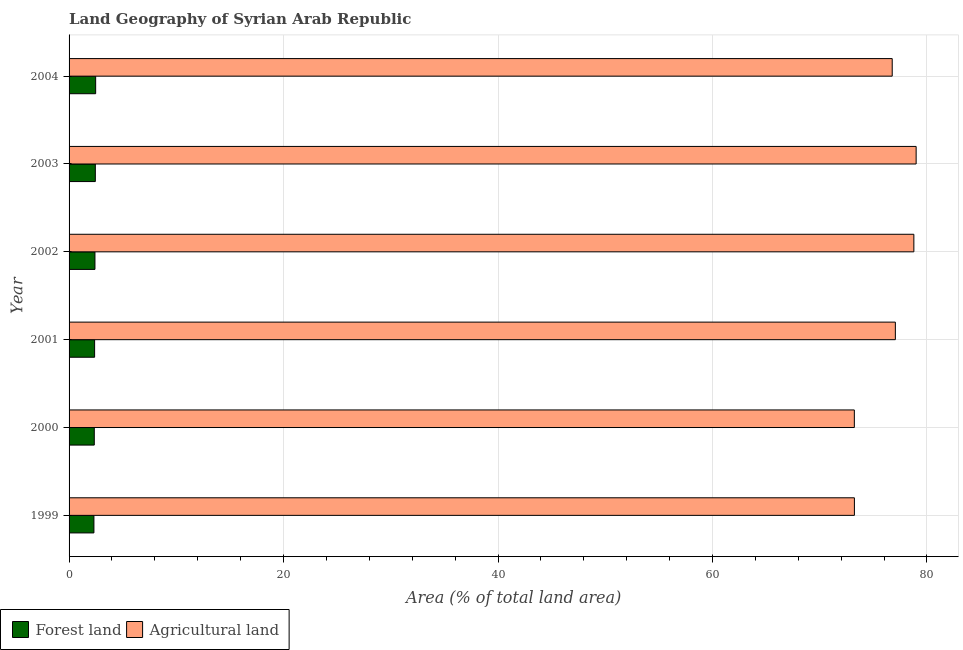How many groups of bars are there?
Your answer should be compact. 6. Are the number of bars per tick equal to the number of legend labels?
Make the answer very short. Yes. Are the number of bars on each tick of the Y-axis equal?
Provide a short and direct response. Yes. What is the percentage of land area under forests in 1999?
Provide a succinct answer. 2.32. Across all years, what is the maximum percentage of land area under agriculture?
Ensure brevity in your answer.  78.99. Across all years, what is the minimum percentage of land area under agriculture?
Provide a succinct answer. 73.23. What is the total percentage of land area under forests in the graph?
Provide a short and direct response. 14.39. What is the difference between the percentage of land area under agriculture in 2001 and that in 2004?
Offer a very short reply. 0.29. What is the difference between the percentage of land area under agriculture in 2001 and the percentage of land area under forests in 2003?
Offer a terse response. 74.61. What is the average percentage of land area under agriculture per year?
Offer a very short reply. 76.34. In the year 2003, what is the difference between the percentage of land area under forests and percentage of land area under agriculture?
Your answer should be compact. -76.54. Is the difference between the percentage of land area under forests in 2000 and 2001 greater than the difference between the percentage of land area under agriculture in 2000 and 2001?
Your answer should be compact. Yes. What is the difference between the highest and the second highest percentage of land area under forests?
Ensure brevity in your answer.  0.03. What is the difference between the highest and the lowest percentage of land area under forests?
Keep it short and to the point. 0.16. In how many years, is the percentage of land area under forests greater than the average percentage of land area under forests taken over all years?
Make the answer very short. 3. Is the sum of the percentage of land area under agriculture in 2000 and 2002 greater than the maximum percentage of land area under forests across all years?
Provide a short and direct response. Yes. What does the 1st bar from the top in 2004 represents?
Provide a succinct answer. Agricultural land. What does the 1st bar from the bottom in 2000 represents?
Provide a succinct answer. Forest land. How many bars are there?
Your response must be concise. 12. Are all the bars in the graph horizontal?
Provide a short and direct response. Yes. What is the difference between two consecutive major ticks on the X-axis?
Offer a terse response. 20. Does the graph contain any zero values?
Ensure brevity in your answer.  No. Does the graph contain grids?
Ensure brevity in your answer.  Yes. Where does the legend appear in the graph?
Your answer should be compact. Bottom left. How many legend labels are there?
Offer a very short reply. 2. How are the legend labels stacked?
Offer a very short reply. Horizontal. What is the title of the graph?
Give a very brief answer. Land Geography of Syrian Arab Republic. What is the label or title of the X-axis?
Offer a very short reply. Area (% of total land area). What is the label or title of the Y-axis?
Ensure brevity in your answer.  Year. What is the Area (% of total land area) of Forest land in 1999?
Provide a succinct answer. 2.32. What is the Area (% of total land area) of Agricultural land in 1999?
Your answer should be very brief. 73.23. What is the Area (% of total land area) in Forest land in 2000?
Offer a terse response. 2.35. What is the Area (% of total land area) in Agricultural land in 2000?
Your response must be concise. 73.23. What is the Area (% of total land area) of Forest land in 2001?
Give a very brief answer. 2.38. What is the Area (% of total land area) in Agricultural land in 2001?
Make the answer very short. 77.05. What is the Area (% of total land area) of Forest land in 2002?
Offer a terse response. 2.41. What is the Area (% of total land area) in Agricultural land in 2002?
Your answer should be very brief. 78.78. What is the Area (% of total land area) of Forest land in 2003?
Provide a short and direct response. 2.45. What is the Area (% of total land area) in Agricultural land in 2003?
Keep it short and to the point. 78.99. What is the Area (% of total land area) in Forest land in 2004?
Offer a terse response. 2.48. What is the Area (% of total land area) in Agricultural land in 2004?
Your response must be concise. 76.76. Across all years, what is the maximum Area (% of total land area) in Forest land?
Give a very brief answer. 2.48. Across all years, what is the maximum Area (% of total land area) in Agricultural land?
Provide a short and direct response. 78.99. Across all years, what is the minimum Area (% of total land area) of Forest land?
Provide a short and direct response. 2.32. Across all years, what is the minimum Area (% of total land area) in Agricultural land?
Your response must be concise. 73.23. What is the total Area (% of total land area) of Forest land in the graph?
Offer a terse response. 14.39. What is the total Area (% of total land area) in Agricultural land in the graph?
Offer a very short reply. 458.05. What is the difference between the Area (% of total land area) in Forest land in 1999 and that in 2000?
Offer a terse response. -0.03. What is the difference between the Area (% of total land area) of Agricultural land in 1999 and that in 2000?
Your answer should be very brief. 0.01. What is the difference between the Area (% of total land area) in Forest land in 1999 and that in 2001?
Your answer should be compact. -0.06. What is the difference between the Area (% of total land area) in Agricultural land in 1999 and that in 2001?
Your response must be concise. -3.82. What is the difference between the Area (% of total land area) of Forest land in 1999 and that in 2002?
Provide a succinct answer. -0.1. What is the difference between the Area (% of total land area) of Agricultural land in 1999 and that in 2002?
Give a very brief answer. -5.54. What is the difference between the Area (% of total land area) of Forest land in 1999 and that in 2003?
Offer a very short reply. -0.13. What is the difference between the Area (% of total land area) of Agricultural land in 1999 and that in 2003?
Keep it short and to the point. -5.76. What is the difference between the Area (% of total land area) in Forest land in 1999 and that in 2004?
Ensure brevity in your answer.  -0.16. What is the difference between the Area (% of total land area) of Agricultural land in 1999 and that in 2004?
Your response must be concise. -3.53. What is the difference between the Area (% of total land area) of Forest land in 2000 and that in 2001?
Provide a short and direct response. -0.03. What is the difference between the Area (% of total land area) in Agricultural land in 2000 and that in 2001?
Offer a very short reply. -3.83. What is the difference between the Area (% of total land area) of Forest land in 2000 and that in 2002?
Give a very brief answer. -0.06. What is the difference between the Area (% of total land area) in Agricultural land in 2000 and that in 2002?
Keep it short and to the point. -5.55. What is the difference between the Area (% of total land area) in Forest land in 2000 and that in 2003?
Your answer should be very brief. -0.1. What is the difference between the Area (% of total land area) of Agricultural land in 2000 and that in 2003?
Provide a succinct answer. -5.76. What is the difference between the Area (% of total land area) in Forest land in 2000 and that in 2004?
Make the answer very short. -0.13. What is the difference between the Area (% of total land area) in Agricultural land in 2000 and that in 2004?
Your response must be concise. -3.53. What is the difference between the Area (% of total land area) in Forest land in 2001 and that in 2002?
Your answer should be compact. -0.03. What is the difference between the Area (% of total land area) in Agricultural land in 2001 and that in 2002?
Your answer should be very brief. -1.72. What is the difference between the Area (% of total land area) in Forest land in 2001 and that in 2003?
Make the answer very short. -0.07. What is the difference between the Area (% of total land area) of Agricultural land in 2001 and that in 2003?
Your response must be concise. -1.94. What is the difference between the Area (% of total land area) in Forest land in 2001 and that in 2004?
Your answer should be very brief. -0.1. What is the difference between the Area (% of total land area) in Agricultural land in 2001 and that in 2004?
Your response must be concise. 0.29. What is the difference between the Area (% of total land area) in Forest land in 2002 and that in 2003?
Ensure brevity in your answer.  -0.03. What is the difference between the Area (% of total land area) of Agricultural land in 2002 and that in 2003?
Provide a short and direct response. -0.21. What is the difference between the Area (% of total land area) of Forest land in 2002 and that in 2004?
Keep it short and to the point. -0.07. What is the difference between the Area (% of total land area) of Agricultural land in 2002 and that in 2004?
Make the answer very short. 2.02. What is the difference between the Area (% of total land area) of Forest land in 2003 and that in 2004?
Ensure brevity in your answer.  -0.03. What is the difference between the Area (% of total land area) of Agricultural land in 2003 and that in 2004?
Your answer should be very brief. 2.23. What is the difference between the Area (% of total land area) of Forest land in 1999 and the Area (% of total land area) of Agricultural land in 2000?
Ensure brevity in your answer.  -70.91. What is the difference between the Area (% of total land area) in Forest land in 1999 and the Area (% of total land area) in Agricultural land in 2001?
Offer a very short reply. -74.74. What is the difference between the Area (% of total land area) of Forest land in 1999 and the Area (% of total land area) of Agricultural land in 2002?
Your answer should be very brief. -76.46. What is the difference between the Area (% of total land area) in Forest land in 1999 and the Area (% of total land area) in Agricultural land in 2003?
Keep it short and to the point. -76.67. What is the difference between the Area (% of total land area) in Forest land in 1999 and the Area (% of total land area) in Agricultural land in 2004?
Provide a short and direct response. -74.44. What is the difference between the Area (% of total land area) in Forest land in 2000 and the Area (% of total land area) in Agricultural land in 2001?
Provide a short and direct response. -74.7. What is the difference between the Area (% of total land area) of Forest land in 2000 and the Area (% of total land area) of Agricultural land in 2002?
Provide a succinct answer. -76.43. What is the difference between the Area (% of total land area) of Forest land in 2000 and the Area (% of total land area) of Agricultural land in 2003?
Offer a very short reply. -76.64. What is the difference between the Area (% of total land area) in Forest land in 2000 and the Area (% of total land area) in Agricultural land in 2004?
Provide a succinct answer. -74.41. What is the difference between the Area (% of total land area) of Forest land in 2001 and the Area (% of total land area) of Agricultural land in 2002?
Keep it short and to the point. -76.4. What is the difference between the Area (% of total land area) of Forest land in 2001 and the Area (% of total land area) of Agricultural land in 2003?
Ensure brevity in your answer.  -76.61. What is the difference between the Area (% of total land area) of Forest land in 2001 and the Area (% of total land area) of Agricultural land in 2004?
Give a very brief answer. -74.38. What is the difference between the Area (% of total land area) of Forest land in 2002 and the Area (% of total land area) of Agricultural land in 2003?
Your response must be concise. -76.58. What is the difference between the Area (% of total land area) in Forest land in 2002 and the Area (% of total land area) in Agricultural land in 2004?
Keep it short and to the point. -74.35. What is the difference between the Area (% of total land area) of Forest land in 2003 and the Area (% of total land area) of Agricultural land in 2004?
Offer a terse response. -74.31. What is the average Area (% of total land area) of Forest land per year?
Give a very brief answer. 2.4. What is the average Area (% of total land area) in Agricultural land per year?
Ensure brevity in your answer.  76.34. In the year 1999, what is the difference between the Area (% of total land area) of Forest land and Area (% of total land area) of Agricultural land?
Your response must be concise. -70.92. In the year 2000, what is the difference between the Area (% of total land area) of Forest land and Area (% of total land area) of Agricultural land?
Offer a terse response. -70.88. In the year 2001, what is the difference between the Area (% of total land area) of Forest land and Area (% of total land area) of Agricultural land?
Offer a very short reply. -74.67. In the year 2002, what is the difference between the Area (% of total land area) of Forest land and Area (% of total land area) of Agricultural land?
Offer a terse response. -76.37. In the year 2003, what is the difference between the Area (% of total land area) in Forest land and Area (% of total land area) in Agricultural land?
Keep it short and to the point. -76.54. In the year 2004, what is the difference between the Area (% of total land area) in Forest land and Area (% of total land area) in Agricultural land?
Ensure brevity in your answer.  -74.28. What is the ratio of the Area (% of total land area) of Forest land in 1999 to that in 2000?
Offer a terse response. 0.99. What is the ratio of the Area (% of total land area) in Forest land in 1999 to that in 2001?
Ensure brevity in your answer.  0.97. What is the ratio of the Area (% of total land area) of Agricultural land in 1999 to that in 2001?
Offer a terse response. 0.95. What is the ratio of the Area (% of total land area) of Forest land in 1999 to that in 2002?
Provide a succinct answer. 0.96. What is the ratio of the Area (% of total land area) of Agricultural land in 1999 to that in 2002?
Give a very brief answer. 0.93. What is the ratio of the Area (% of total land area) of Forest land in 1999 to that in 2003?
Your answer should be very brief. 0.95. What is the ratio of the Area (% of total land area) of Agricultural land in 1999 to that in 2003?
Your response must be concise. 0.93. What is the ratio of the Area (% of total land area) of Forest land in 1999 to that in 2004?
Your answer should be very brief. 0.93. What is the ratio of the Area (% of total land area) of Agricultural land in 1999 to that in 2004?
Offer a very short reply. 0.95. What is the ratio of the Area (% of total land area) in Agricultural land in 2000 to that in 2001?
Your answer should be very brief. 0.95. What is the ratio of the Area (% of total land area) in Forest land in 2000 to that in 2002?
Your answer should be compact. 0.97. What is the ratio of the Area (% of total land area) in Agricultural land in 2000 to that in 2002?
Ensure brevity in your answer.  0.93. What is the ratio of the Area (% of total land area) in Forest land in 2000 to that in 2003?
Your answer should be very brief. 0.96. What is the ratio of the Area (% of total land area) of Agricultural land in 2000 to that in 2003?
Provide a succinct answer. 0.93. What is the ratio of the Area (% of total land area) in Forest land in 2000 to that in 2004?
Provide a succinct answer. 0.95. What is the ratio of the Area (% of total land area) in Agricultural land in 2000 to that in 2004?
Give a very brief answer. 0.95. What is the ratio of the Area (% of total land area) of Forest land in 2001 to that in 2002?
Make the answer very short. 0.99. What is the ratio of the Area (% of total land area) in Agricultural land in 2001 to that in 2002?
Offer a very short reply. 0.98. What is the ratio of the Area (% of total land area) in Forest land in 2001 to that in 2003?
Your answer should be compact. 0.97. What is the ratio of the Area (% of total land area) in Agricultural land in 2001 to that in 2003?
Your response must be concise. 0.98. What is the ratio of the Area (% of total land area) of Forest land in 2001 to that in 2004?
Provide a short and direct response. 0.96. What is the ratio of the Area (% of total land area) of Forest land in 2002 to that in 2003?
Your response must be concise. 0.99. What is the ratio of the Area (% of total land area) in Agricultural land in 2002 to that in 2003?
Your answer should be compact. 1. What is the ratio of the Area (% of total land area) in Forest land in 2002 to that in 2004?
Your answer should be compact. 0.97. What is the ratio of the Area (% of total land area) in Agricultural land in 2002 to that in 2004?
Make the answer very short. 1.03. What is the ratio of the Area (% of total land area) of Forest land in 2003 to that in 2004?
Offer a very short reply. 0.99. What is the ratio of the Area (% of total land area) in Agricultural land in 2003 to that in 2004?
Make the answer very short. 1.03. What is the difference between the highest and the second highest Area (% of total land area) of Forest land?
Ensure brevity in your answer.  0.03. What is the difference between the highest and the second highest Area (% of total land area) in Agricultural land?
Provide a succinct answer. 0.21. What is the difference between the highest and the lowest Area (% of total land area) in Forest land?
Provide a succinct answer. 0.16. What is the difference between the highest and the lowest Area (% of total land area) in Agricultural land?
Offer a terse response. 5.76. 